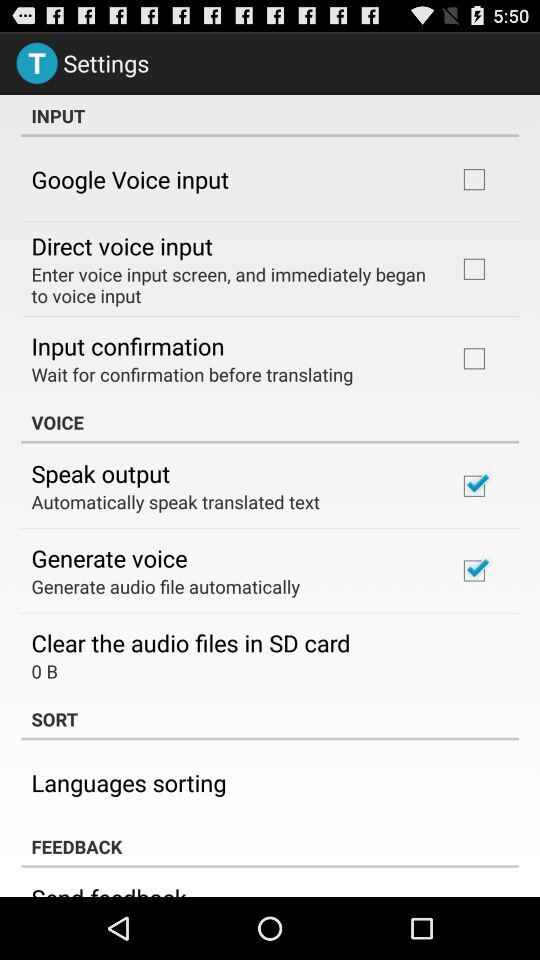Which options have been checked? The options "Speak output" and "Generate voice" have been checked. 